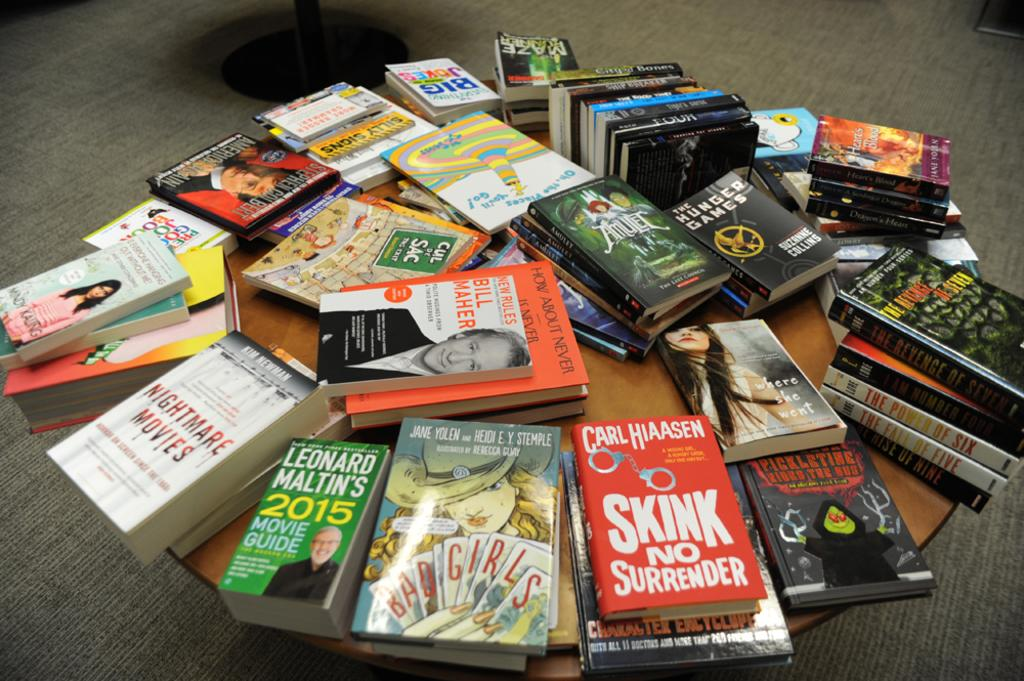<image>
Relay a brief, clear account of the picture shown. Books are on a table and one says SKINK NO SURRENDER on the cover. 